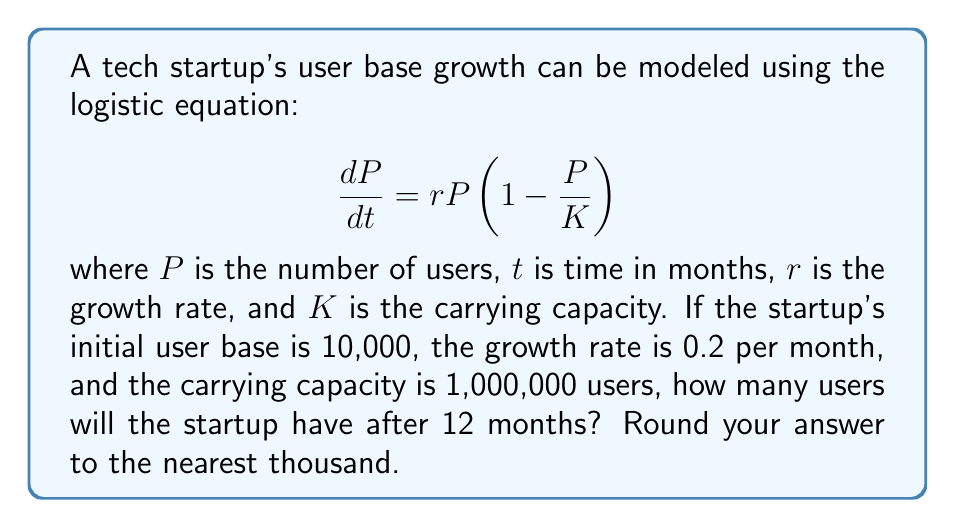Give your solution to this math problem. To solve this problem, we need to use the solution to the logistic equation, which is:

$$P(t) = \frac{K}{1 + (\frac{K}{P_0} - 1)e^{-rt}}$$

Where:
$P(t)$ is the population at time $t$
$K$ is the carrying capacity
$P_0$ is the initial population
$r$ is the growth rate
$t$ is the time

Given:
$K = 1,000,000$
$P_0 = 10,000$
$r = 0.2$
$t = 12$

Let's substitute these values into the equation:

$$P(12) = \frac{1,000,000}{1 + (\frac{1,000,000}{10,000} - 1)e^{-0.2(12)}}$$

$$= \frac{1,000,000}{1 + (99)e^{-2.4}}$$

Now, let's calculate this step by step:

1. Calculate $e^{-2.4}$:
   $e^{-2.4} \approx 0.0907$

2. Multiply by 99:
   $99 * 0.0907 \approx 8.9793$

3. Add 1:
   $1 + 8.9793 = 9.9793$

4. Divide 1,000,000 by this result:
   $\frac{1,000,000}{9.9793} \approx 100,208$

5. Round to the nearest thousand:
   $100,208 \approx 100,000$

Therefore, after 12 months, the startup will have approximately 100,000 users.
Answer: 100,000 users 